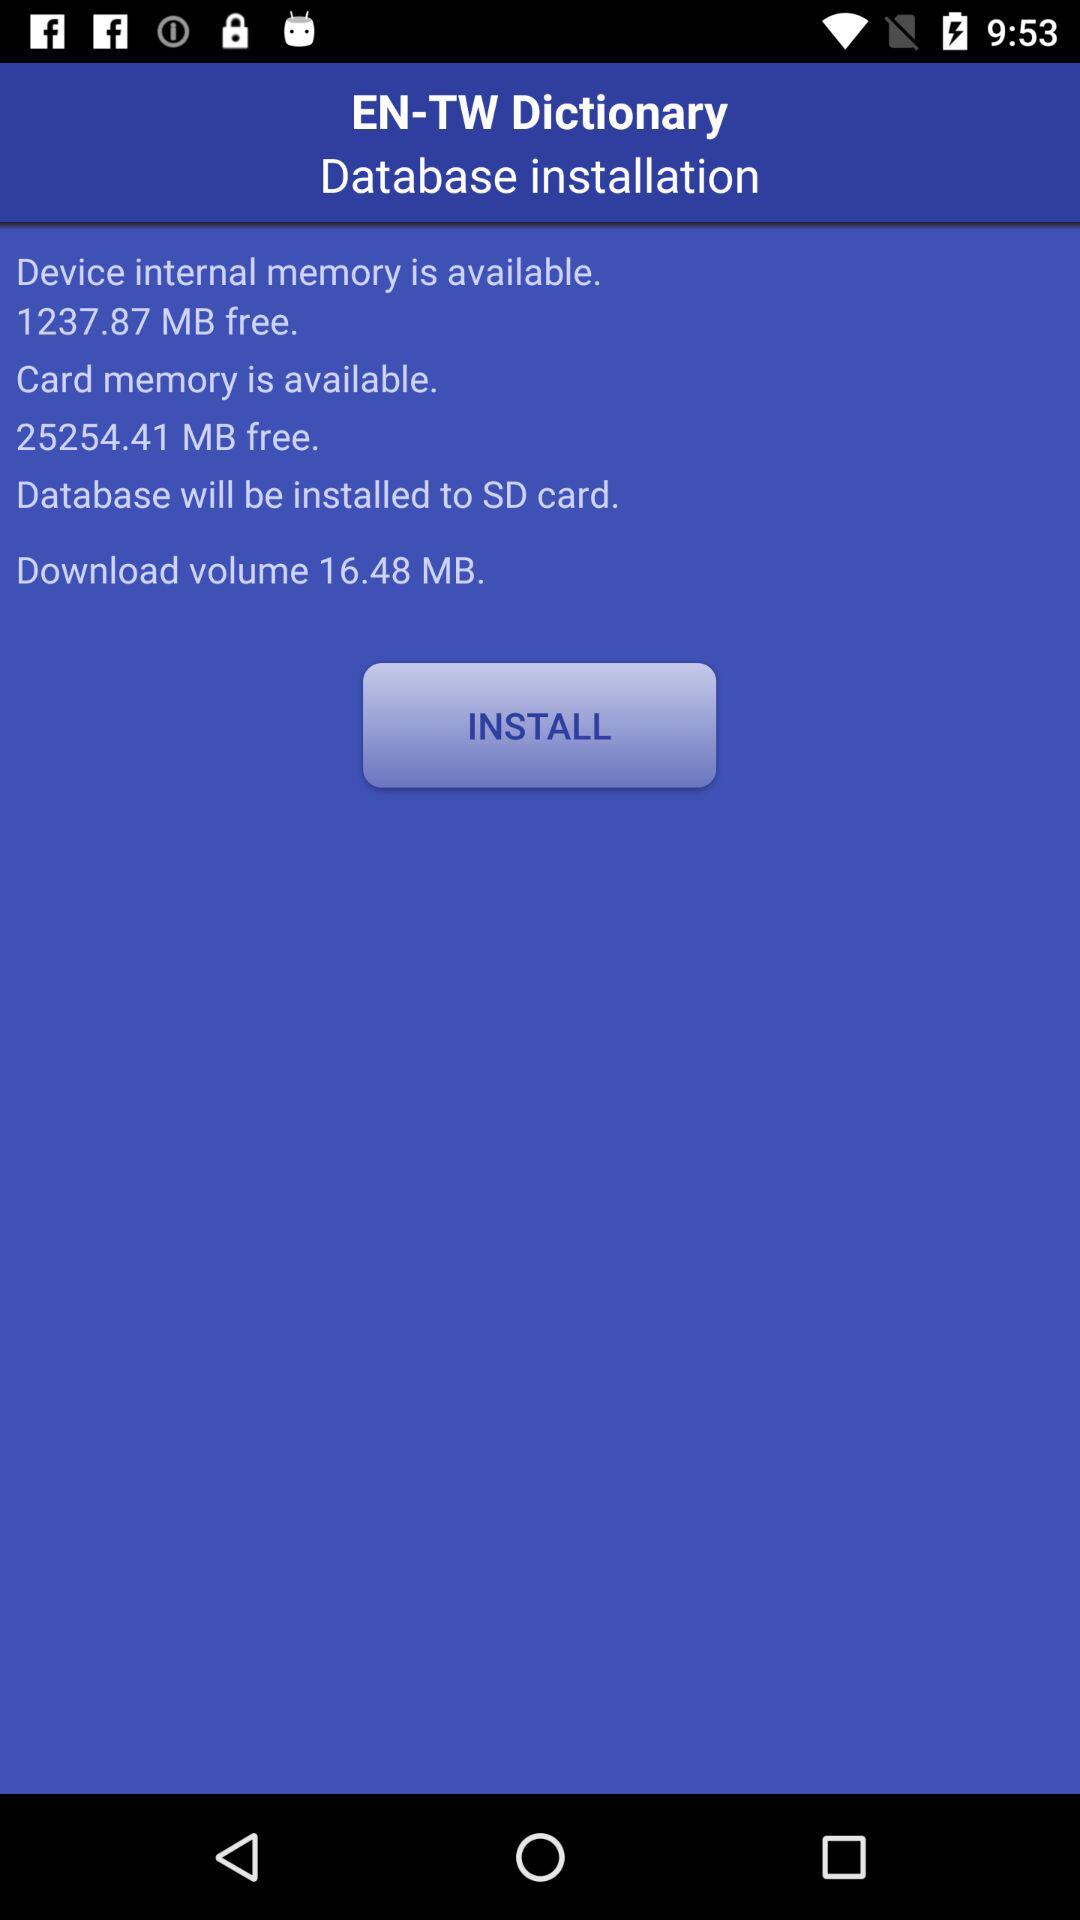Which memory has more space available, the device's internal memory or the SD card?
Answer the question using a single word or phrase. SD card 